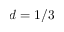<formula> <loc_0><loc_0><loc_500><loc_500>d = 1 / 3</formula> 